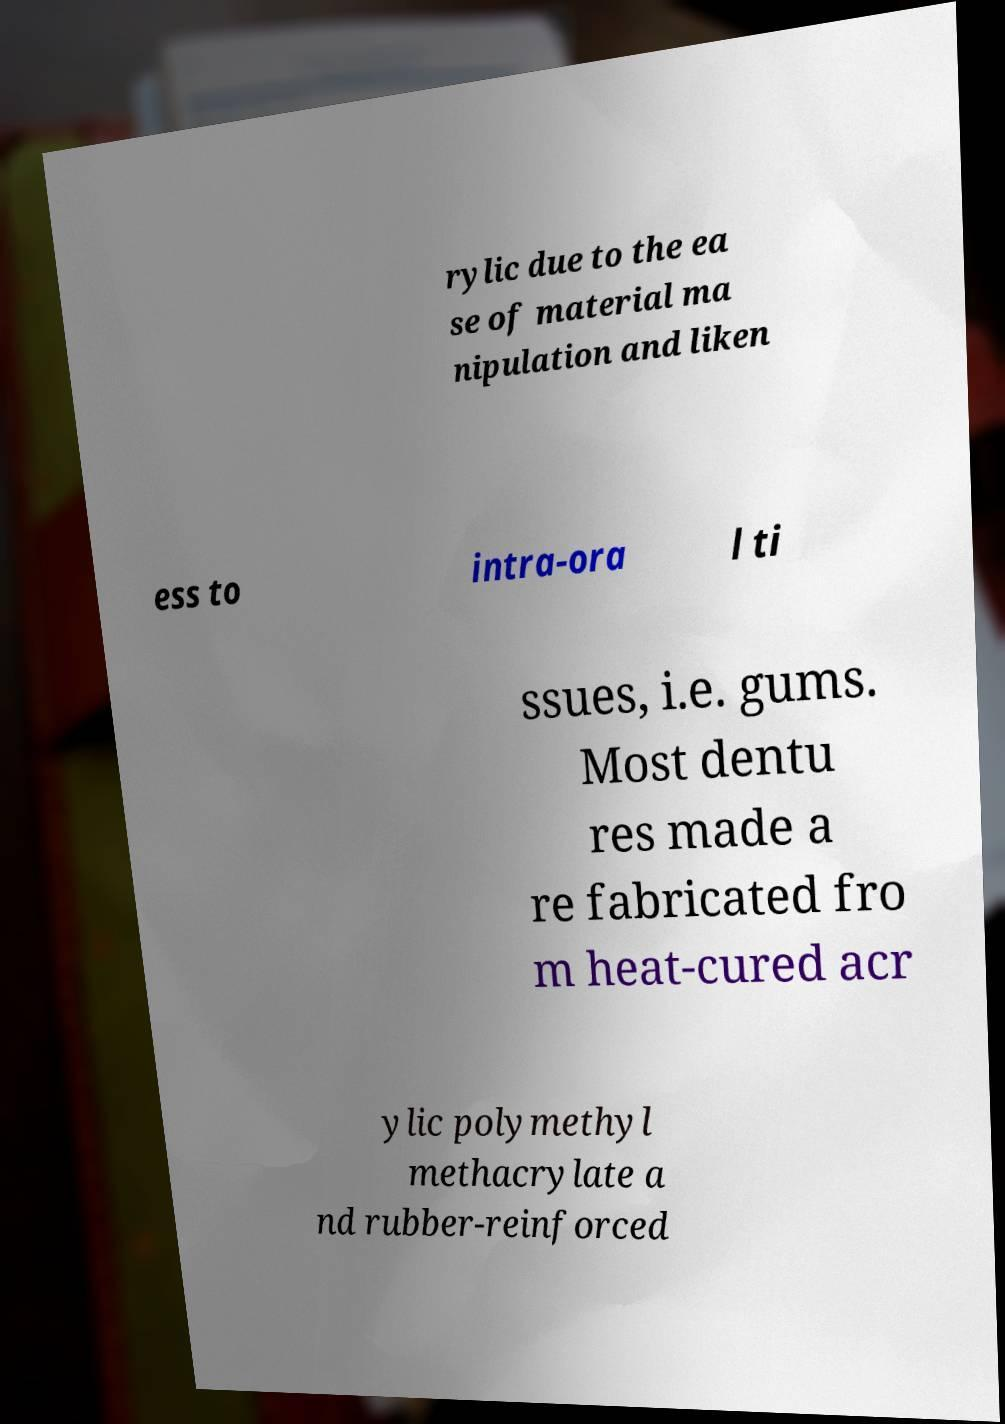Could you assist in decoding the text presented in this image and type it out clearly? rylic due to the ea se of material ma nipulation and liken ess to intra-ora l ti ssues, i.e. gums. Most dentu res made a re fabricated fro m heat-cured acr ylic polymethyl methacrylate a nd rubber-reinforced 